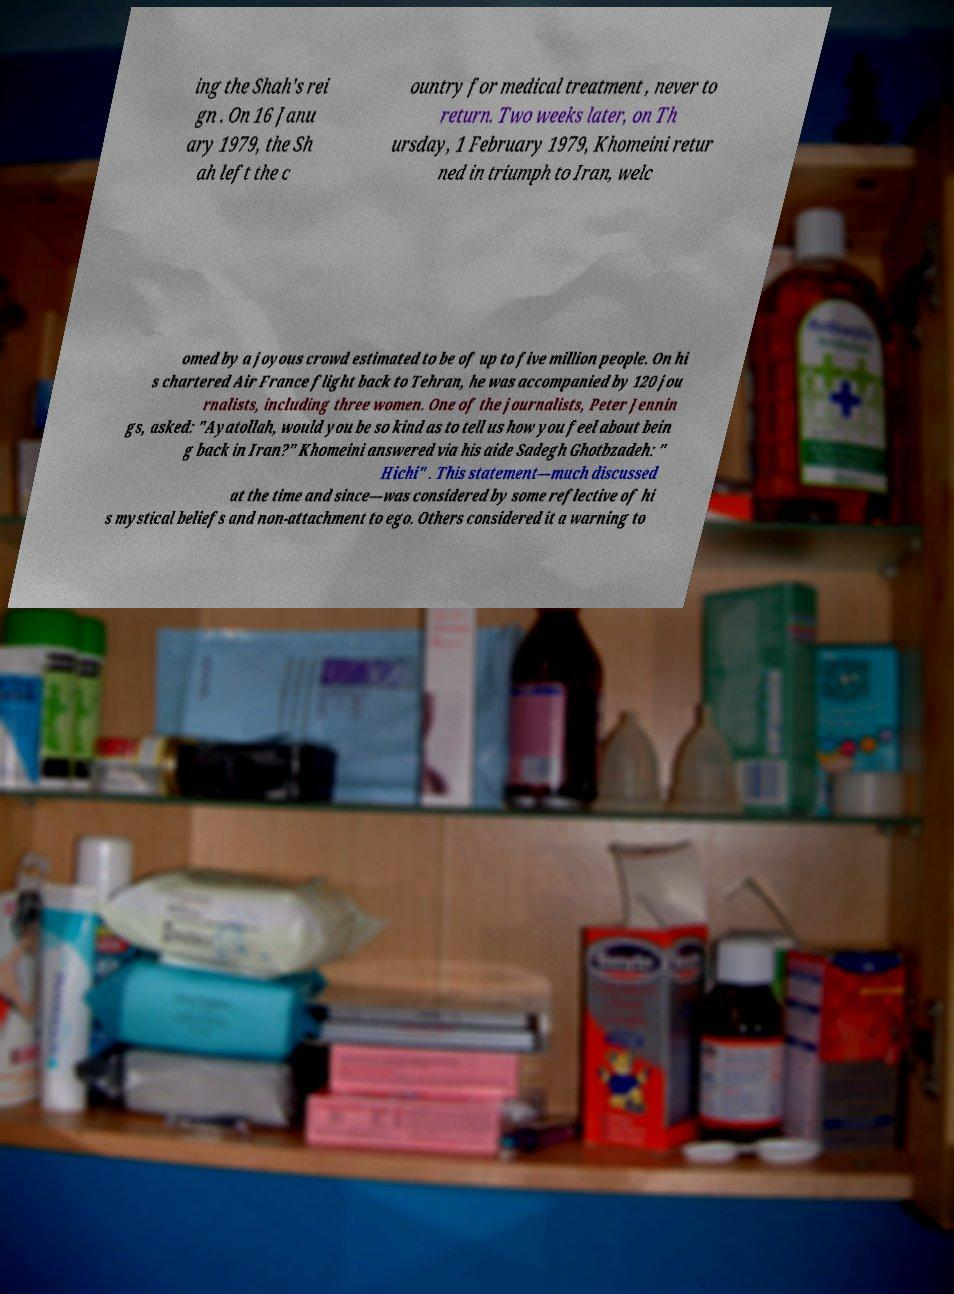Could you assist in decoding the text presented in this image and type it out clearly? ing the Shah's rei gn . On 16 Janu ary 1979, the Sh ah left the c ountry for medical treatment , never to return. Two weeks later, on Th ursday, 1 February 1979, Khomeini retur ned in triumph to Iran, welc omed by a joyous crowd estimated to be of up to five million people. On hi s chartered Air France flight back to Tehran, he was accompanied by 120 jou rnalists, including three women. One of the journalists, Peter Jennin gs, asked: "Ayatollah, would you be so kind as to tell us how you feel about bein g back in Iran?" Khomeini answered via his aide Sadegh Ghotbzadeh: " Hichi" . This statement—much discussed at the time and since—was considered by some reflective of hi s mystical beliefs and non-attachment to ego. Others considered it a warning to 